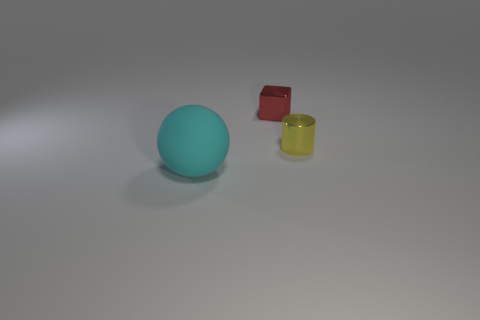Is there any particular object that seems out of place or different from the others? While all objects are simple geometric shapes, the red cube stands out as it appears to have a more matte surface, contrasting with the shiny surfaces of the teal sphere and yellow cylinder. 